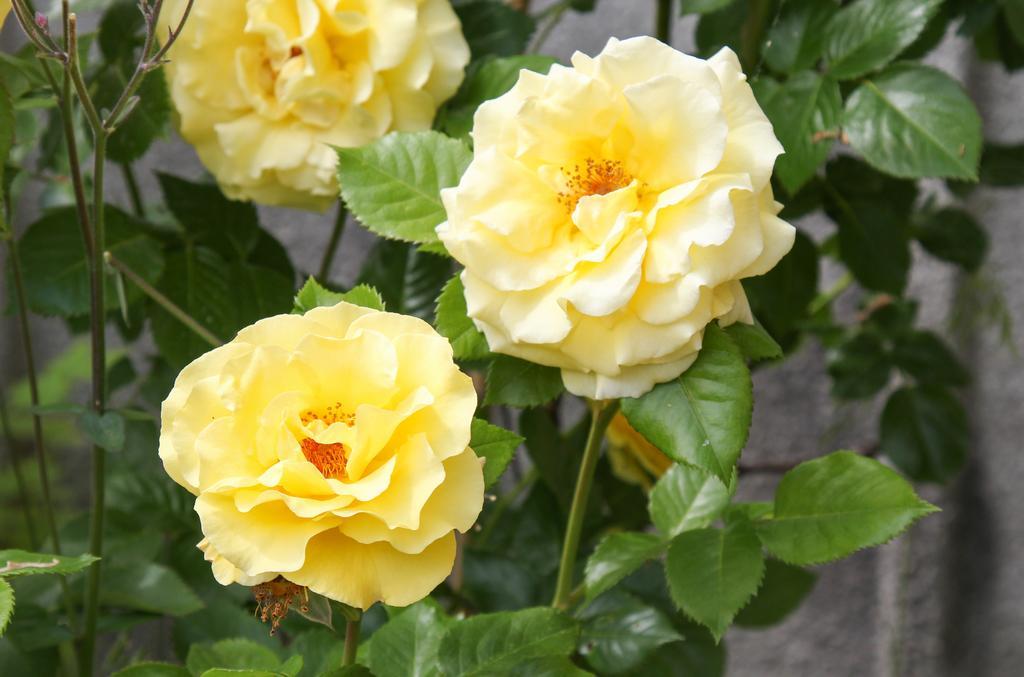In one or two sentences, can you explain what this image depicts? In this picture we can see few flowers and plants. 